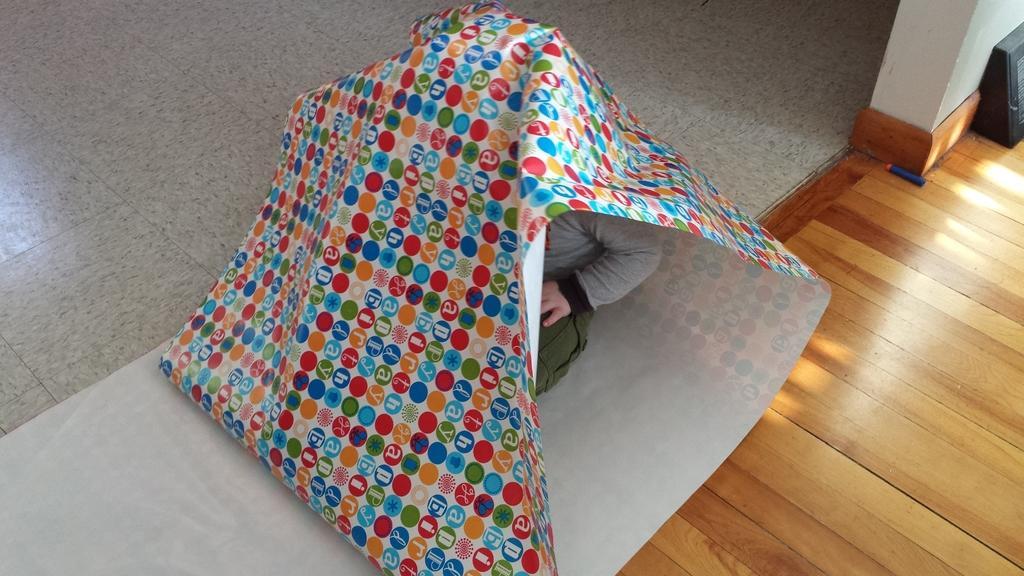In one or two sentences, can you explain what this image depicts? In this image we can see a person covered under a colorful sheet and we can also see a wooden surface and a black object. 